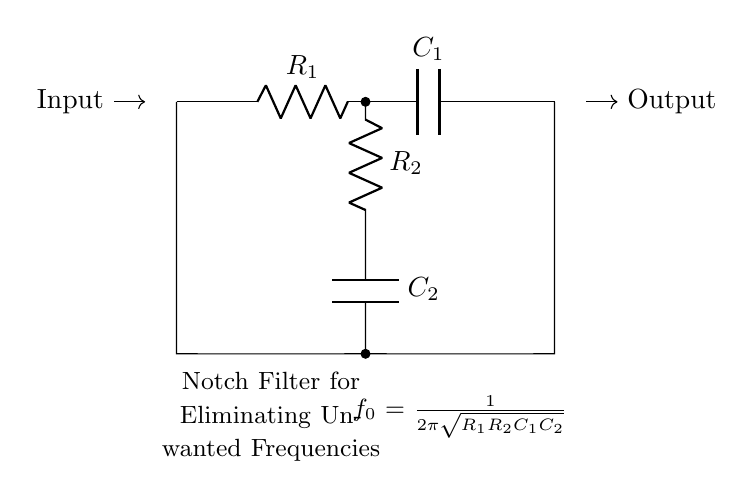What components are used in this notch filter circuit? The circuit features two resistors (R1, R2) and two capacitors (C1, C2), all connected to form a notch filter.
Answer: Resistors and capacitors What is the purpose of the notch filter? The notch filter is designed to eliminate unwanted frequencies, specifically background noise that can interfere with audio quality and emotional impact of sound.
Answer: Eliminate unwanted frequencies What is the relationship shown in the formula provided in the circuit? The formula given indicates that the cutoff frequency (f0) is determined by the values of both resistors and both capacitors, indicating how they affect the filter's performance.
Answer: Frequency relationship How many nodes are present in the circuit? There are six connection points or nodes shown in the circuit diagram where components connect together, indicating the flow of electrical signals.
Answer: Six nodes What happens at the output of this circuit? At the output, the unwanted frequencies are significantly reduced, allowing only the desired audio signal to pass through for playback or further processing.
Answer: Reduced unwanted frequencies What would happen if R1 or C1 was changed? Changing R1 or C1 would alter the cutoff frequency (f0), affecting which frequencies are filtered out of the audio signal. This could either allow more unwanted frequencies to pass or cut off desired audio.
Answer: Altered cutoff frequency 